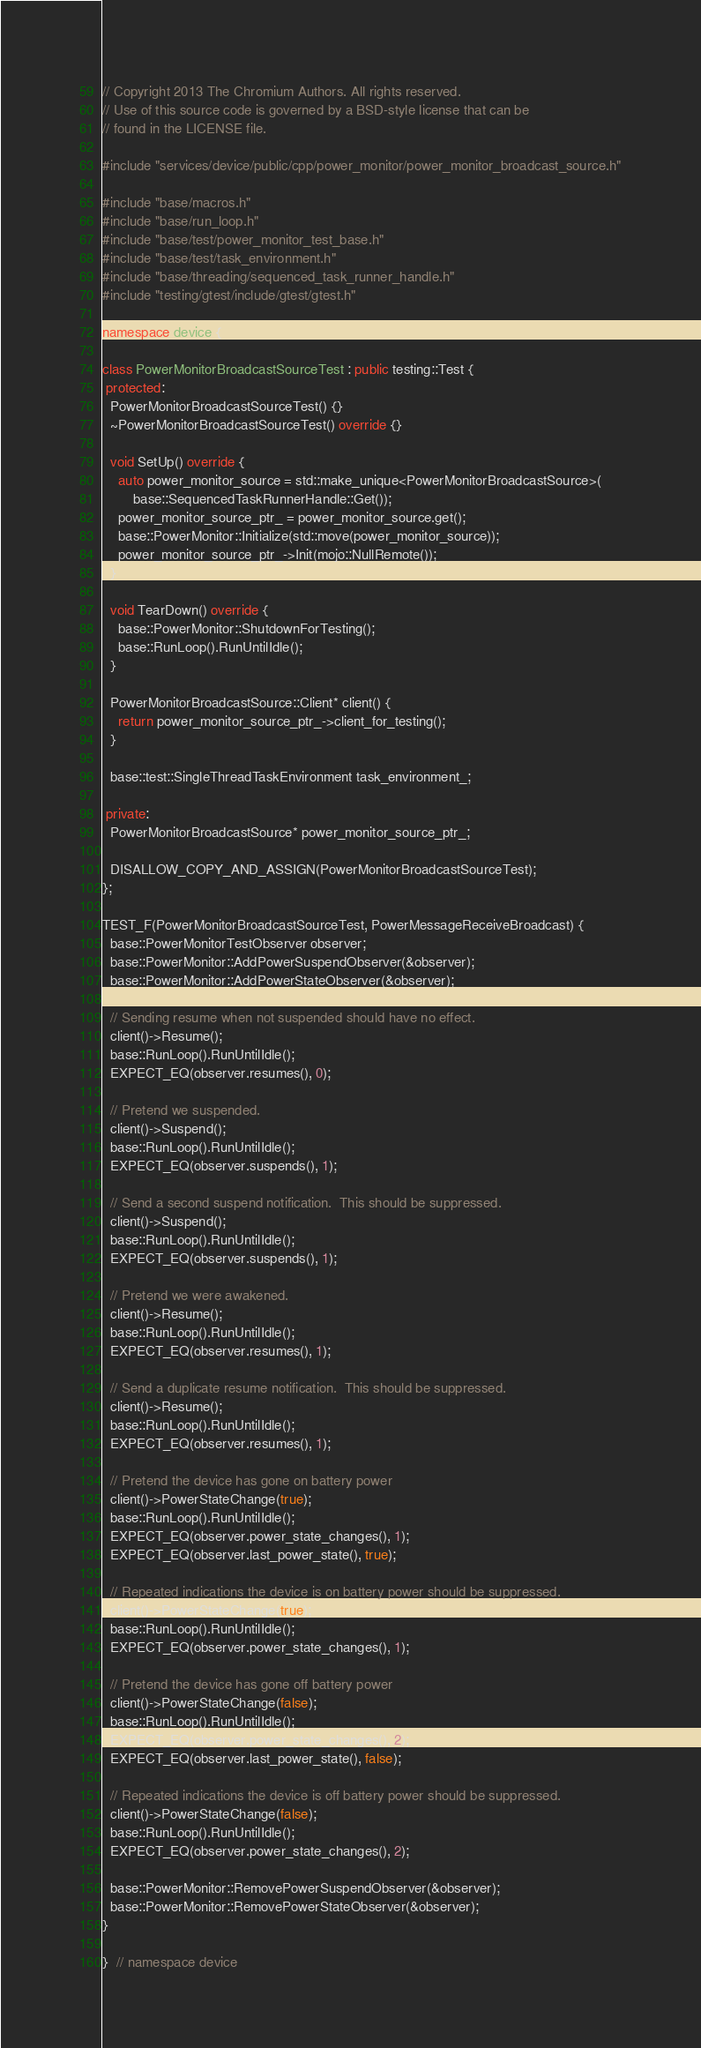<code> <loc_0><loc_0><loc_500><loc_500><_C++_>// Copyright 2013 The Chromium Authors. All rights reserved.
// Use of this source code is governed by a BSD-style license that can be
// found in the LICENSE file.

#include "services/device/public/cpp/power_monitor/power_monitor_broadcast_source.h"

#include "base/macros.h"
#include "base/run_loop.h"
#include "base/test/power_monitor_test_base.h"
#include "base/test/task_environment.h"
#include "base/threading/sequenced_task_runner_handle.h"
#include "testing/gtest/include/gtest/gtest.h"

namespace device {

class PowerMonitorBroadcastSourceTest : public testing::Test {
 protected:
  PowerMonitorBroadcastSourceTest() {}
  ~PowerMonitorBroadcastSourceTest() override {}

  void SetUp() override {
    auto power_monitor_source = std::make_unique<PowerMonitorBroadcastSource>(
        base::SequencedTaskRunnerHandle::Get());
    power_monitor_source_ptr_ = power_monitor_source.get();
    base::PowerMonitor::Initialize(std::move(power_monitor_source));
    power_monitor_source_ptr_->Init(mojo::NullRemote());
  }

  void TearDown() override {
    base::PowerMonitor::ShutdownForTesting();
    base::RunLoop().RunUntilIdle();
  }

  PowerMonitorBroadcastSource::Client* client() {
    return power_monitor_source_ptr_->client_for_testing();
  }

  base::test::SingleThreadTaskEnvironment task_environment_;

 private:
  PowerMonitorBroadcastSource* power_monitor_source_ptr_;

  DISALLOW_COPY_AND_ASSIGN(PowerMonitorBroadcastSourceTest);
};

TEST_F(PowerMonitorBroadcastSourceTest, PowerMessageReceiveBroadcast) {
  base::PowerMonitorTestObserver observer;
  base::PowerMonitor::AddPowerSuspendObserver(&observer);
  base::PowerMonitor::AddPowerStateObserver(&observer);

  // Sending resume when not suspended should have no effect.
  client()->Resume();
  base::RunLoop().RunUntilIdle();
  EXPECT_EQ(observer.resumes(), 0);

  // Pretend we suspended.
  client()->Suspend();
  base::RunLoop().RunUntilIdle();
  EXPECT_EQ(observer.suspends(), 1);

  // Send a second suspend notification.  This should be suppressed.
  client()->Suspend();
  base::RunLoop().RunUntilIdle();
  EXPECT_EQ(observer.suspends(), 1);

  // Pretend we were awakened.
  client()->Resume();
  base::RunLoop().RunUntilIdle();
  EXPECT_EQ(observer.resumes(), 1);

  // Send a duplicate resume notification.  This should be suppressed.
  client()->Resume();
  base::RunLoop().RunUntilIdle();
  EXPECT_EQ(observer.resumes(), 1);

  // Pretend the device has gone on battery power
  client()->PowerStateChange(true);
  base::RunLoop().RunUntilIdle();
  EXPECT_EQ(observer.power_state_changes(), 1);
  EXPECT_EQ(observer.last_power_state(), true);

  // Repeated indications the device is on battery power should be suppressed.
  client()->PowerStateChange(true);
  base::RunLoop().RunUntilIdle();
  EXPECT_EQ(observer.power_state_changes(), 1);

  // Pretend the device has gone off battery power
  client()->PowerStateChange(false);
  base::RunLoop().RunUntilIdle();
  EXPECT_EQ(observer.power_state_changes(), 2);
  EXPECT_EQ(observer.last_power_state(), false);

  // Repeated indications the device is off battery power should be suppressed.
  client()->PowerStateChange(false);
  base::RunLoop().RunUntilIdle();
  EXPECT_EQ(observer.power_state_changes(), 2);

  base::PowerMonitor::RemovePowerSuspendObserver(&observer);
  base::PowerMonitor::RemovePowerStateObserver(&observer);
}

}  // namespace device
</code> 